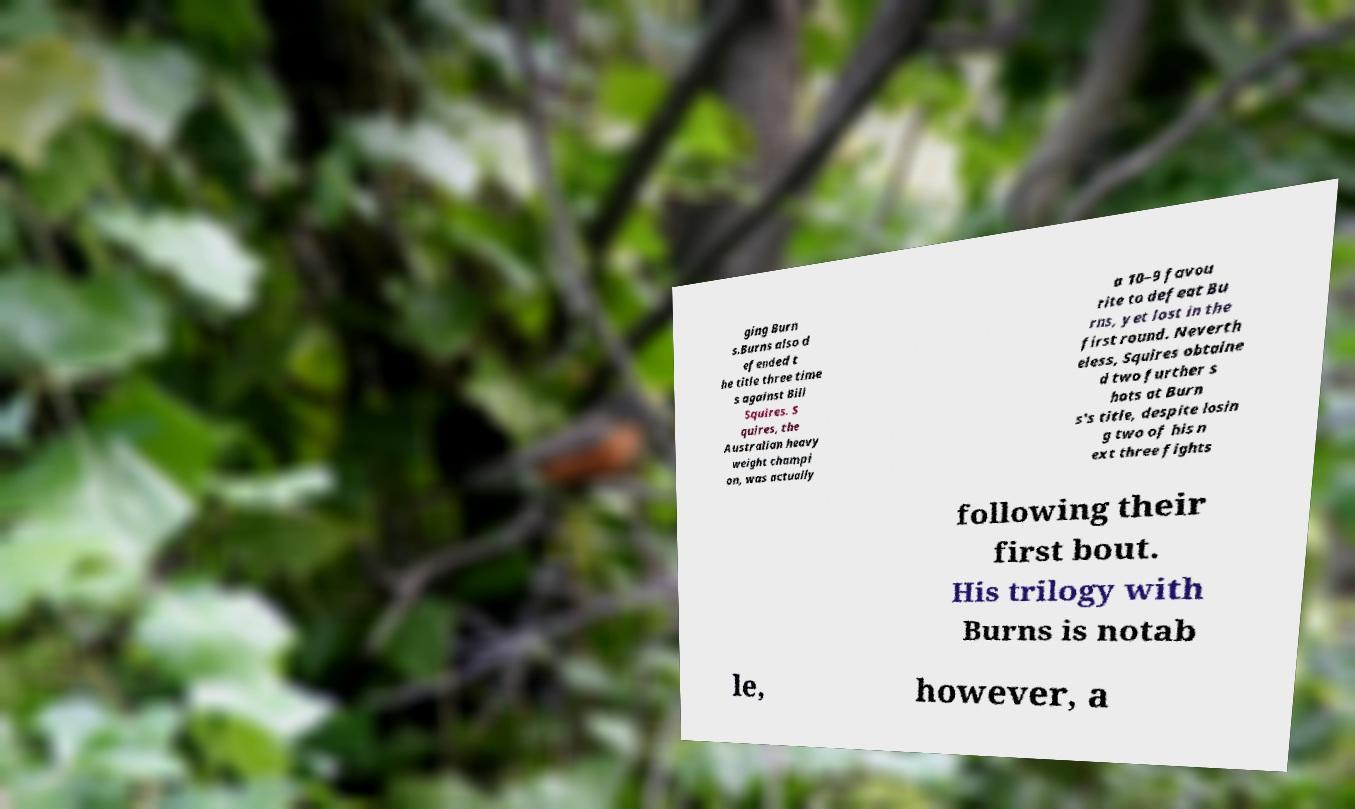For documentation purposes, I need the text within this image transcribed. Could you provide that? ging Burn s.Burns also d efended t he title three time s against Bill Squires. S quires, the Australian heavy weight champi on, was actually a 10–9 favou rite to defeat Bu rns, yet lost in the first round. Neverth eless, Squires obtaine d two further s hots at Burn s's title, despite losin g two of his n ext three fights following their first bout. His trilogy with Burns is notab le, however, a 